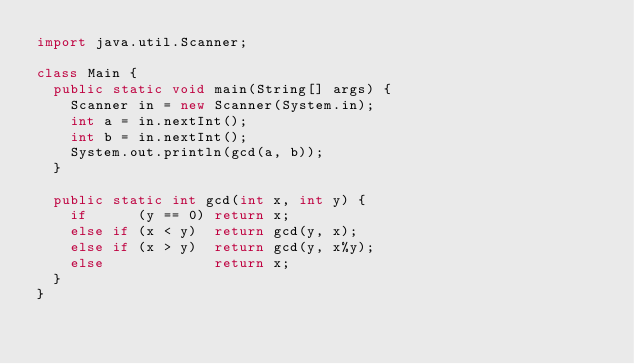Convert code to text. <code><loc_0><loc_0><loc_500><loc_500><_Java_>import java.util.Scanner;

class Main {  
  public static void main(String[] args) {
    Scanner in = new Scanner(System.in);
    int a = in.nextInt();
    int b = in.nextInt();
    System.out.println(gcd(a, b));
  }
  
  public static int gcd(int x, int y) {
    if      (y == 0) return x;
    else if (x < y)  return gcd(y, x);
    else if (x > y)  return gcd(y, x%y);
    else             return x;
  }
}</code> 